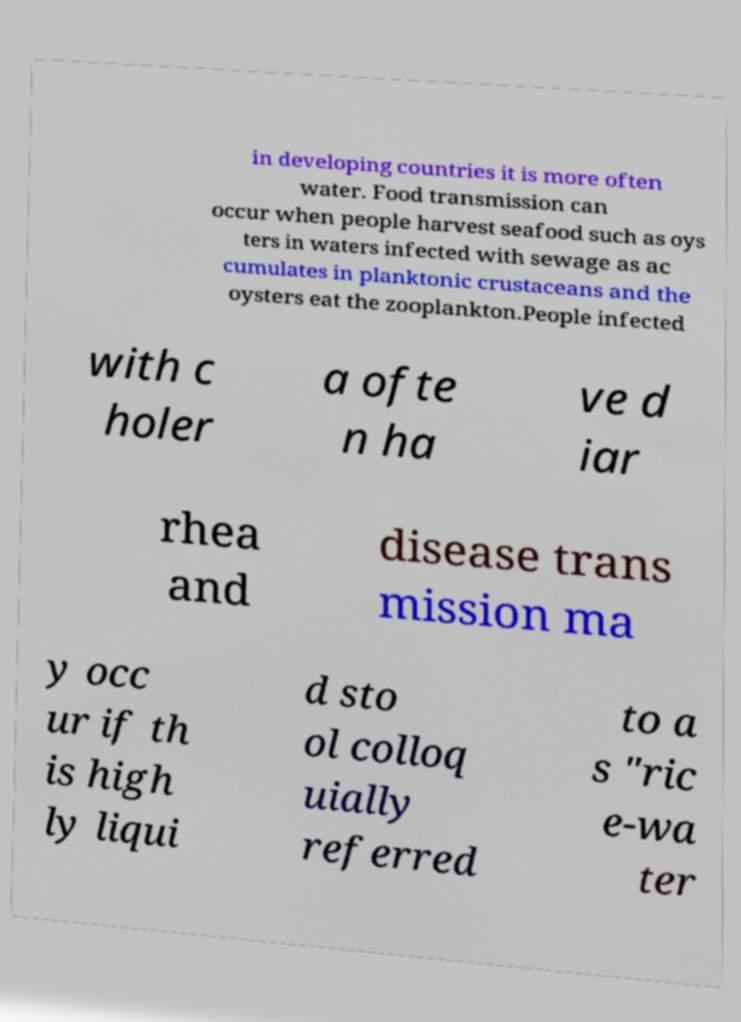Can you accurately transcribe the text from the provided image for me? in developing countries it is more often water. Food transmission can occur when people harvest seafood such as oys ters in waters infected with sewage as ac cumulates in planktonic crustaceans and the oysters eat the zooplankton.People infected with c holer a ofte n ha ve d iar rhea and disease trans mission ma y occ ur if th is high ly liqui d sto ol colloq uially referred to a s "ric e-wa ter 